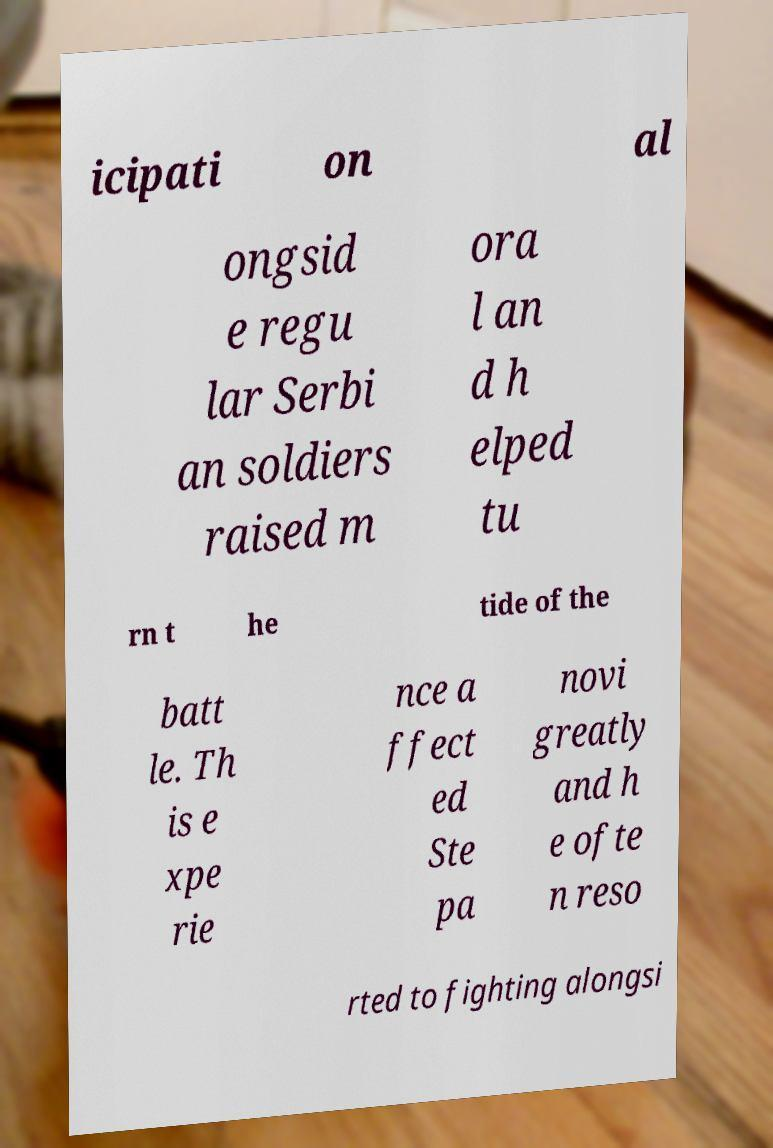What messages or text are displayed in this image? I need them in a readable, typed format. icipati on al ongsid e regu lar Serbi an soldiers raised m ora l an d h elped tu rn t he tide of the batt le. Th is e xpe rie nce a ffect ed Ste pa novi greatly and h e ofte n reso rted to fighting alongsi 